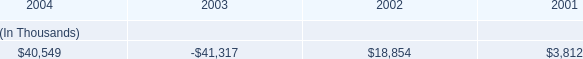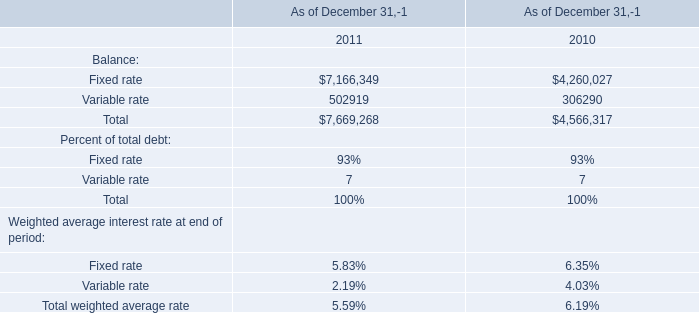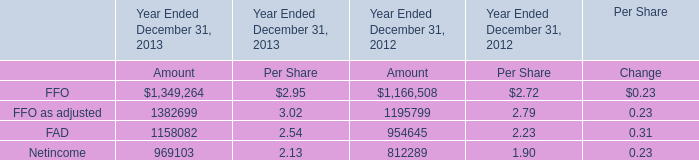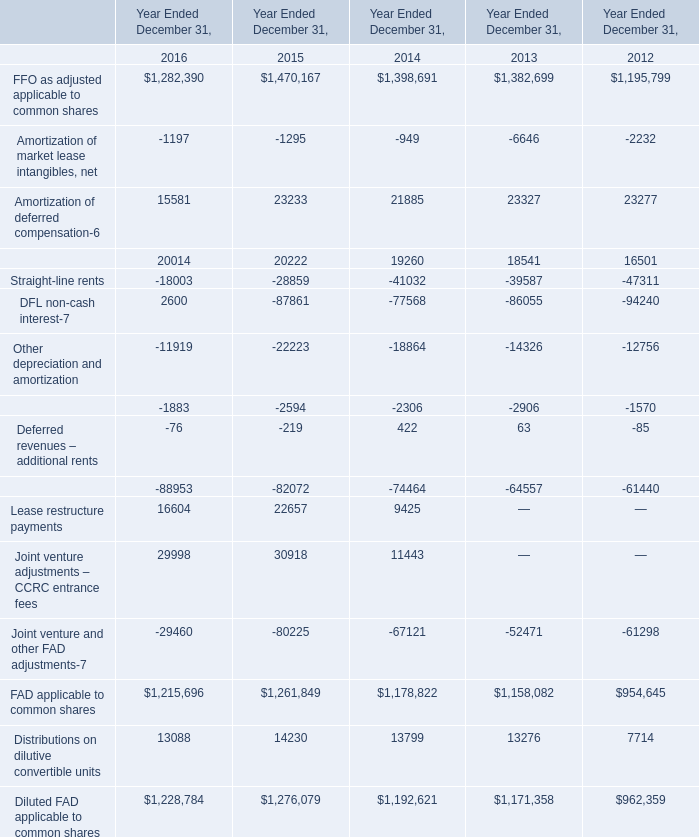In the year with the most FFO as adjusted applicable to common shares, what is the growth rate of Amortization of deferred compensation-6? 
Computations: ((23233 - 21885) / 23233)
Answer: 0.05802. 